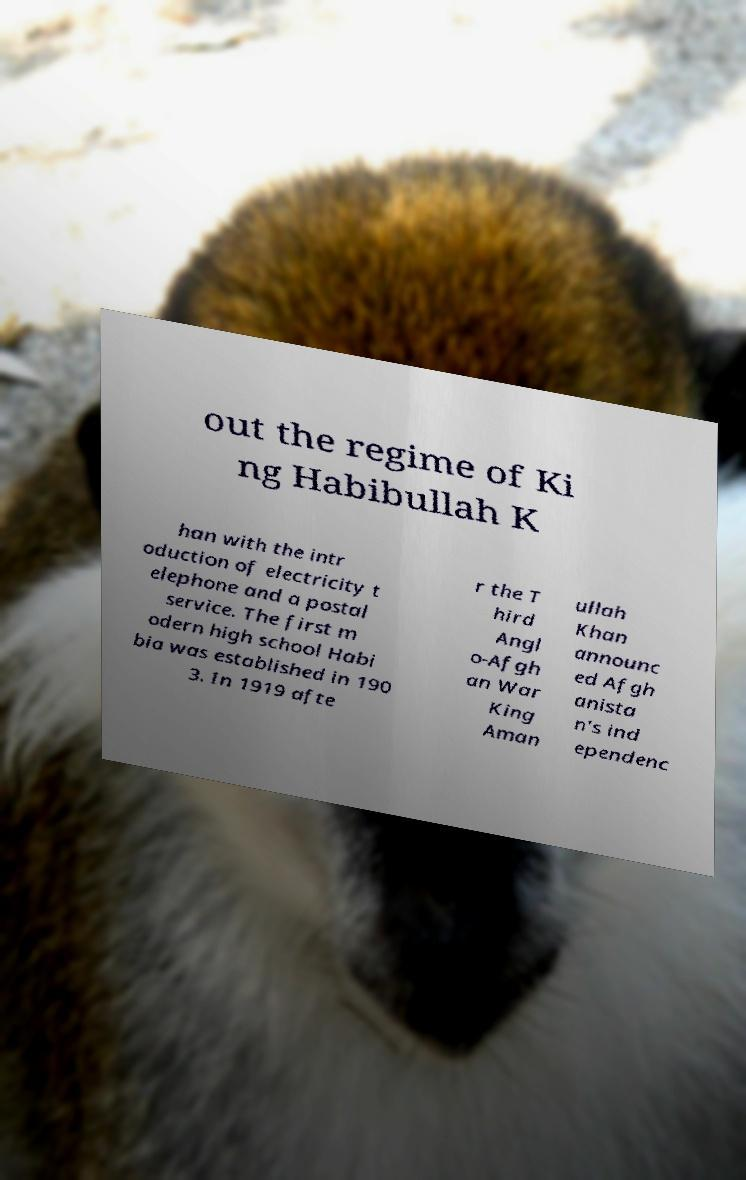Can you accurately transcribe the text from the provided image for me? out the regime of Ki ng Habibullah K han with the intr oduction of electricity t elephone and a postal service. The first m odern high school Habi bia was established in 190 3. In 1919 afte r the T hird Angl o-Afgh an War King Aman ullah Khan announc ed Afgh anista n's ind ependenc 